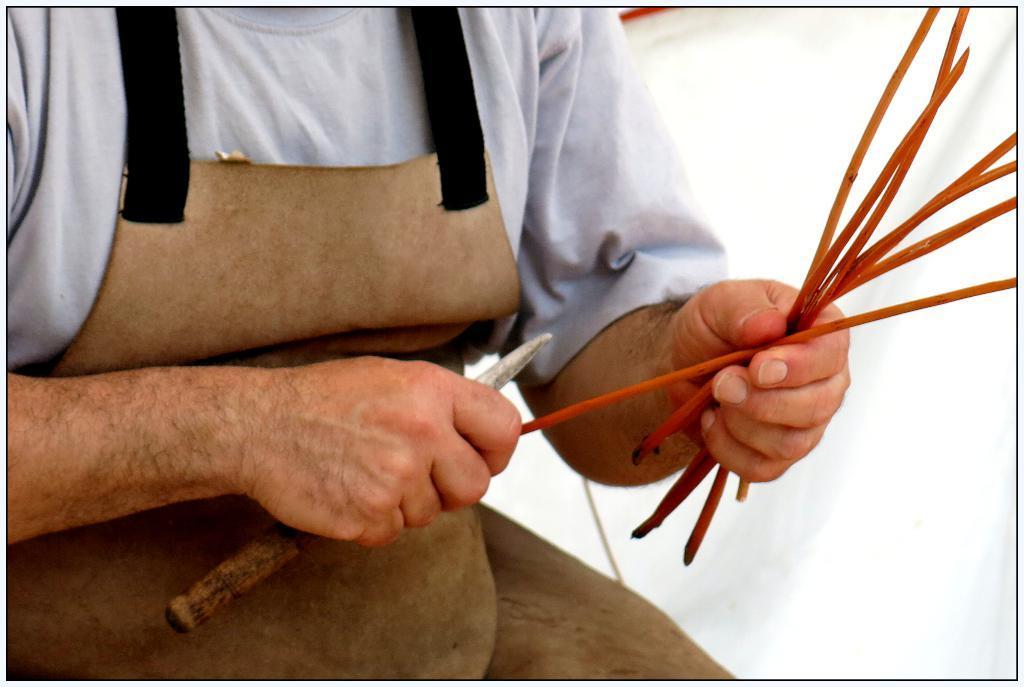Could you give a brief overview of what you see in this image? In this image we can see a person truncated and the person is holding a knife and sticks. The person is wearing an apron. 